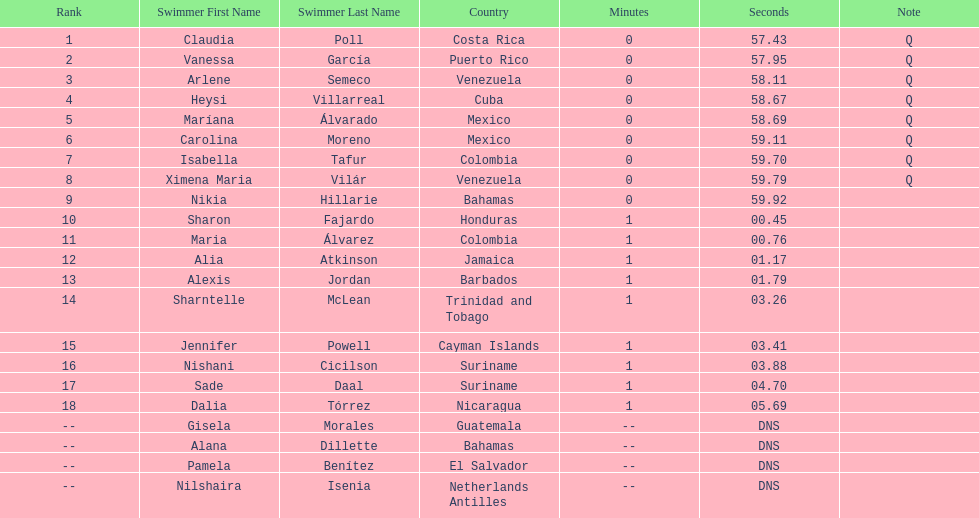Parse the table in full. {'header': ['Rank', 'Swimmer First Name', 'Swimmer Last Name', 'Country', 'Minutes', 'Seconds', 'Note'], 'rows': [['1', 'Claudia', 'Poll', 'Costa Rica', '0', '57.43', 'Q'], ['2', 'Vanessa', 'García', 'Puerto Rico', '0', '57.95', 'Q'], ['3', 'Arlene', 'Semeco', 'Venezuela', '0', '58.11', 'Q'], ['4', 'Heysi', 'Villarreal', 'Cuba', '0', '58.67', 'Q'], ['5', 'Maríana', 'Álvarado', 'Mexico', '0', '58.69', 'Q'], ['6', 'Carolina', 'Moreno', 'Mexico', '0', '59.11', 'Q'], ['7', 'Isabella', 'Tafur', 'Colombia', '0', '59.70', 'Q'], ['8', 'Ximena Maria', 'Vilár', 'Venezuela', '0', '59.79', 'Q'], ['9', 'Nikia', 'Hillarie', 'Bahamas', '0', '59.92', ''], ['10', 'Sharon', 'Fajardo', 'Honduras', '1', '00.45', ''], ['11', 'Maria', 'Álvarez', 'Colombia', '1', '00.76', ''], ['12', 'Alia', 'Atkinson', 'Jamaica', '1', '01.17', ''], ['13', 'Alexis', 'Jordan', 'Barbados', '1', '01.79', ''], ['14', 'Sharntelle', 'McLean', 'Trinidad and Tobago', '1', '03.26', ''], ['15', 'Jennifer', 'Powell', 'Cayman Islands', '1', '03.41', ''], ['16', 'Nishani', 'Cicilson', 'Suriname', '1', '03.88', ''], ['17', 'Sade', 'Daal', 'Suriname', '1', '04.70', ''], ['18', 'Dalia', 'Tórrez', 'Nicaragua', '1', '05.69', ''], ['--', 'Gisela', 'Morales', 'Guatemala', '--', 'DNS', ''], ['--', 'Alana', 'Dillette', 'Bahamas', '--', 'DNS', ''], ['--', 'Pamela', 'Benítez', 'El Salvador', '--', 'DNS', ''], ['--', 'Nilshaira', 'Isenia', 'Netherlands Antilles', '--', 'DNS', '']]} How many swimmers had a time of at least 1:00 9. 